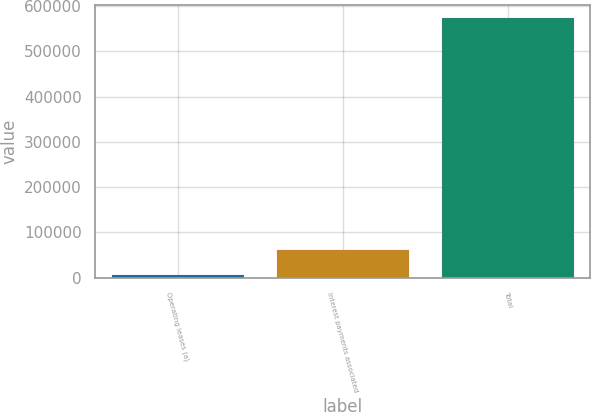Convert chart to OTSL. <chart><loc_0><loc_0><loc_500><loc_500><bar_chart><fcel>Operating leases (a)<fcel>Interest payments associated<fcel>Total<nl><fcel>5263<fcel>61987.9<fcel>572512<nl></chart> 